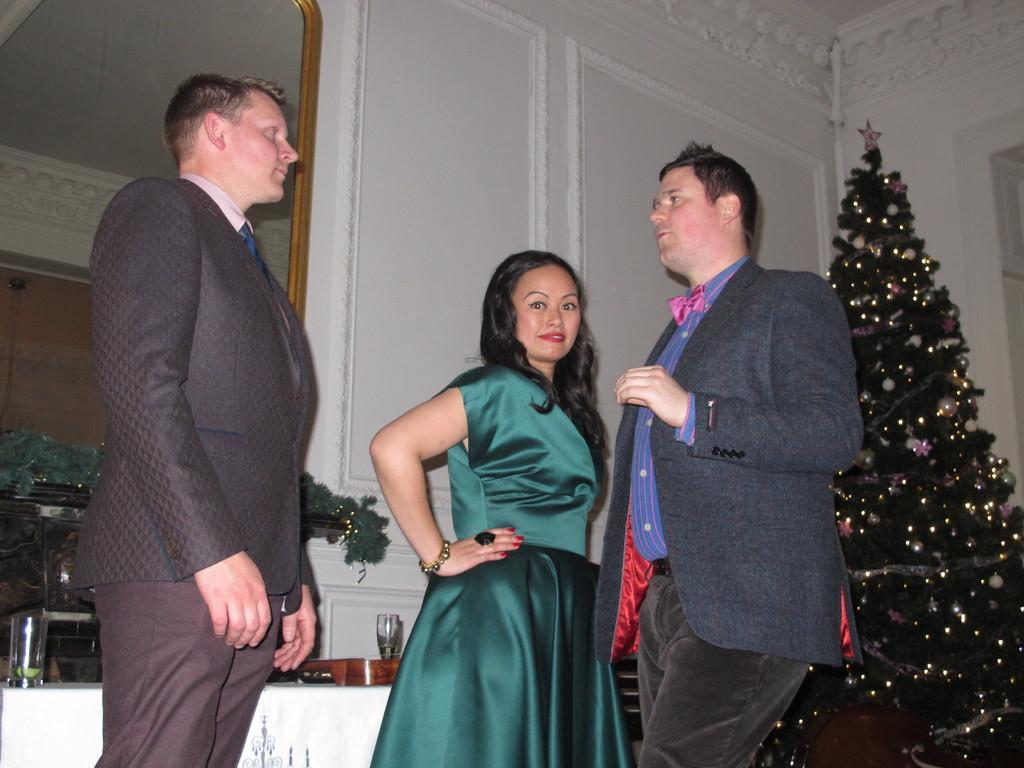Describe this image in one or two sentences. In the picture I can see two men and a woman are standing on the floor among them these two men are wearing black color coats and the woman is wearing green color dress. On the right side of the image I can see the Christmas tree and a white color wall. In the background I can see a table which has some objects on it. 